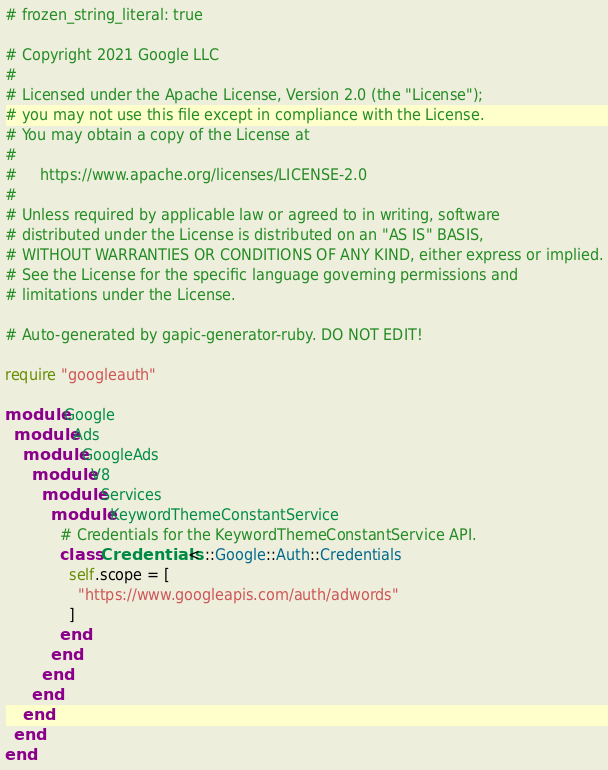<code> <loc_0><loc_0><loc_500><loc_500><_Ruby_># frozen_string_literal: true

# Copyright 2021 Google LLC
#
# Licensed under the Apache License, Version 2.0 (the "License");
# you may not use this file except in compliance with the License.
# You may obtain a copy of the License at
#
#     https://www.apache.org/licenses/LICENSE-2.0
#
# Unless required by applicable law or agreed to in writing, software
# distributed under the License is distributed on an "AS IS" BASIS,
# WITHOUT WARRANTIES OR CONDITIONS OF ANY KIND, either express or implied.
# See the License for the specific language governing permissions and
# limitations under the License.

# Auto-generated by gapic-generator-ruby. DO NOT EDIT!

require "googleauth"

module Google
  module Ads
    module GoogleAds
      module V8
        module Services
          module KeywordThemeConstantService
            # Credentials for the KeywordThemeConstantService API.
            class Credentials < ::Google::Auth::Credentials
              self.scope = [
                "https://www.googleapis.com/auth/adwords"
              ]
            end
          end
        end
      end
    end
  end
end
</code> 